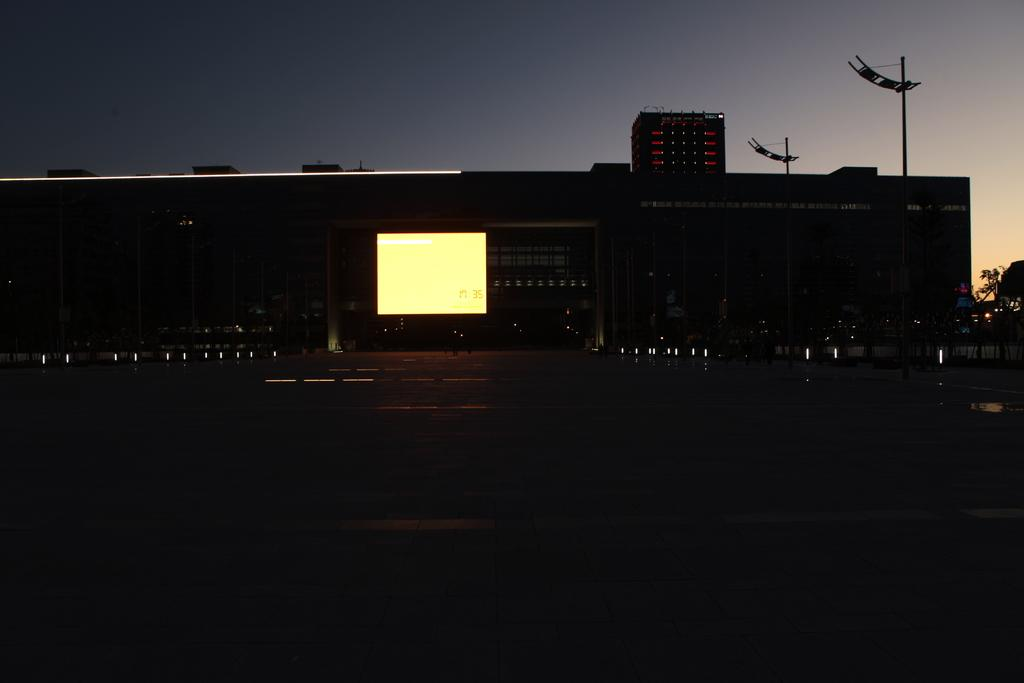At what time of day was the image taken? The image was taken during night time. What can be seen in the foreground of the image? There is a road in the foreground of the image. What is located in the center of the image? There are trees and a building in the center of the image. What else can be found in the center of the image? There is also a screen in the center of the image. What type of basket is being smashed by the building in the image? There is no basket or smashing action present in the image. How many bottles can be seen on the screen in the image? There is no screen with bottles present in the image. 